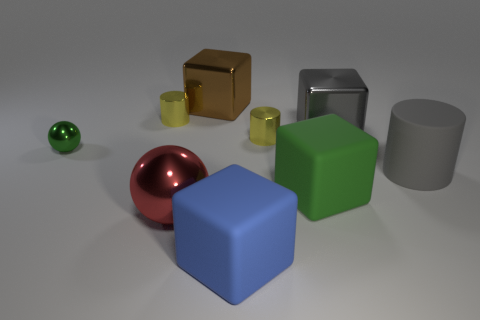Subtract 1 cubes. How many cubes are left? 3 Add 1 brown shiny objects. How many objects exist? 10 Subtract all cylinders. How many objects are left? 6 Subtract 0 red blocks. How many objects are left? 9 Subtract all small blue rubber cubes. Subtract all yellow metallic cylinders. How many objects are left? 7 Add 7 cylinders. How many cylinders are left? 10 Add 5 large metallic things. How many large metallic things exist? 8 